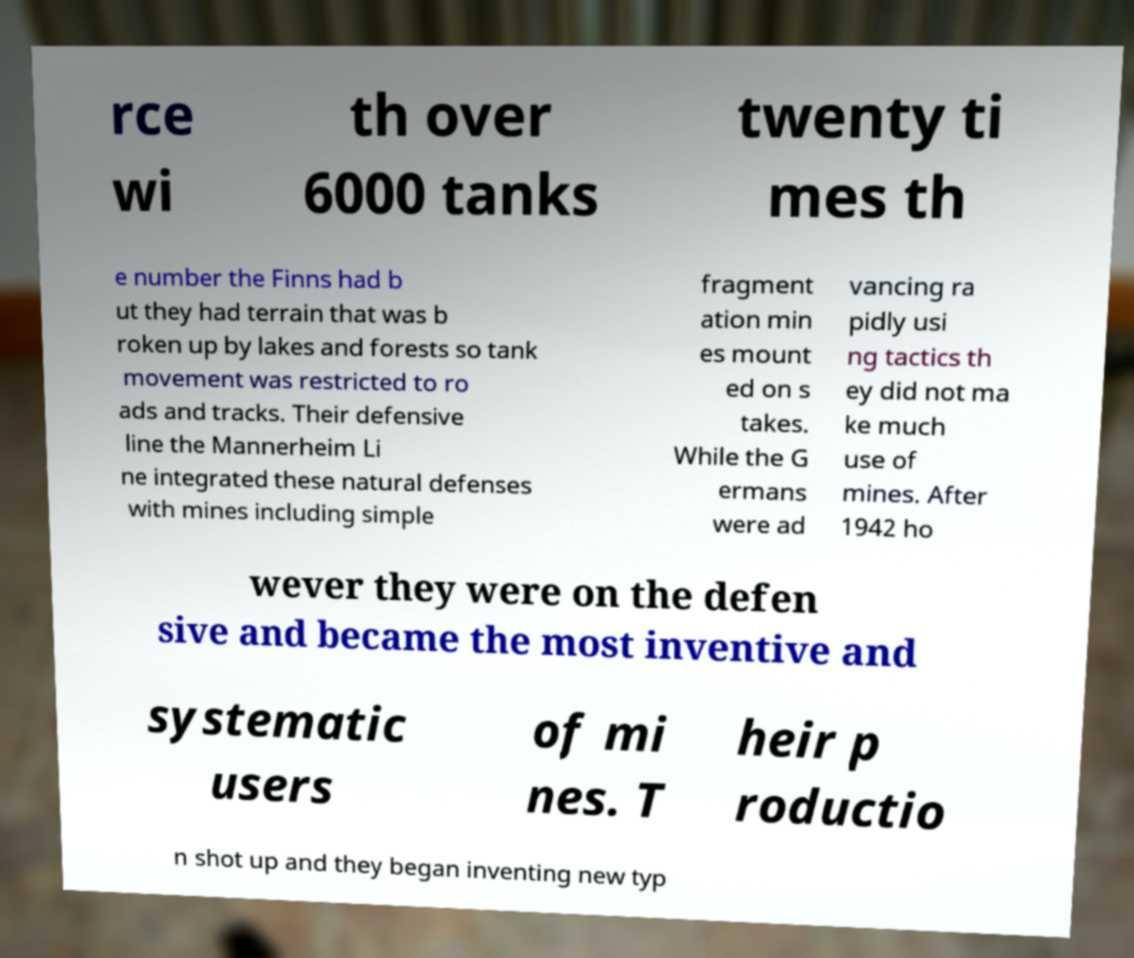Can you accurately transcribe the text from the provided image for me? rce wi th over 6000 tanks twenty ti mes th e number the Finns had b ut they had terrain that was b roken up by lakes and forests so tank movement was restricted to ro ads and tracks. Their defensive line the Mannerheim Li ne integrated these natural defenses with mines including simple fragment ation min es mount ed on s takes. While the G ermans were ad vancing ra pidly usi ng tactics th ey did not ma ke much use of mines. After 1942 ho wever they were on the defen sive and became the most inventive and systematic users of mi nes. T heir p roductio n shot up and they began inventing new typ 